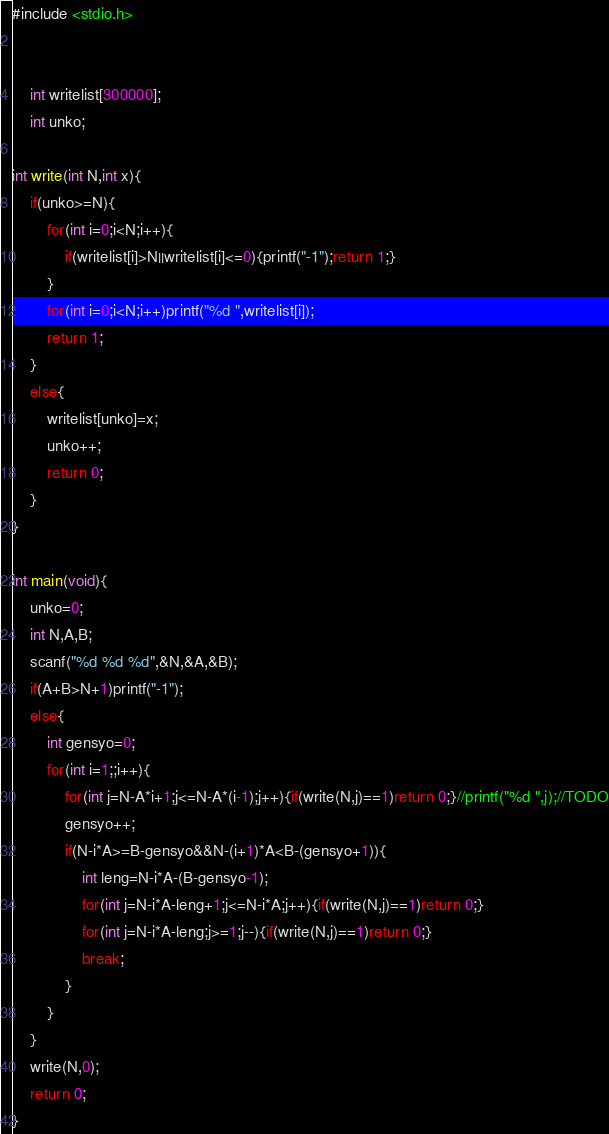<code> <loc_0><loc_0><loc_500><loc_500><_C_>#include <stdio.h>


    int writelist[300000];
    int unko;
    
int write(int N,int x){
    if(unko>=N){
        for(int i=0;i<N;i++){
            if(writelist[i]>N||writelist[i]<=0){printf("-1");return 1;}
        }
        for(int i=0;i<N;i++)printf("%d ",writelist[i]);
        return 1;
    }
    else{
        writelist[unko]=x;
        unko++;
        return 0;
    }
}

int main(void){
    unko=0;
    int N,A,B;
    scanf("%d %d %d",&N,&A,&B);
    if(A+B>N+1)printf("-1");
    else{
        int gensyo=0;
        for(int i=1;;i++){
            for(int j=N-A*i+1;j<=N-A*(i-1);j++){if(write(N,j)==1)return 0;}//printf("%d ",j);//TODO
            gensyo++;
            if(N-i*A>=B-gensyo&&N-(i+1)*A<B-(gensyo+1)){
                int leng=N-i*A-(B-gensyo-1);
                for(int j=N-i*A-leng+1;j<=N-i*A;j++){if(write(N,j)==1)return 0;}
                for(int j=N-i*A-leng;j>=1;j--){if(write(N,j)==1)return 0;}
                break;
            }
        }
    }
    write(N,0);
    return 0;
}
</code> 